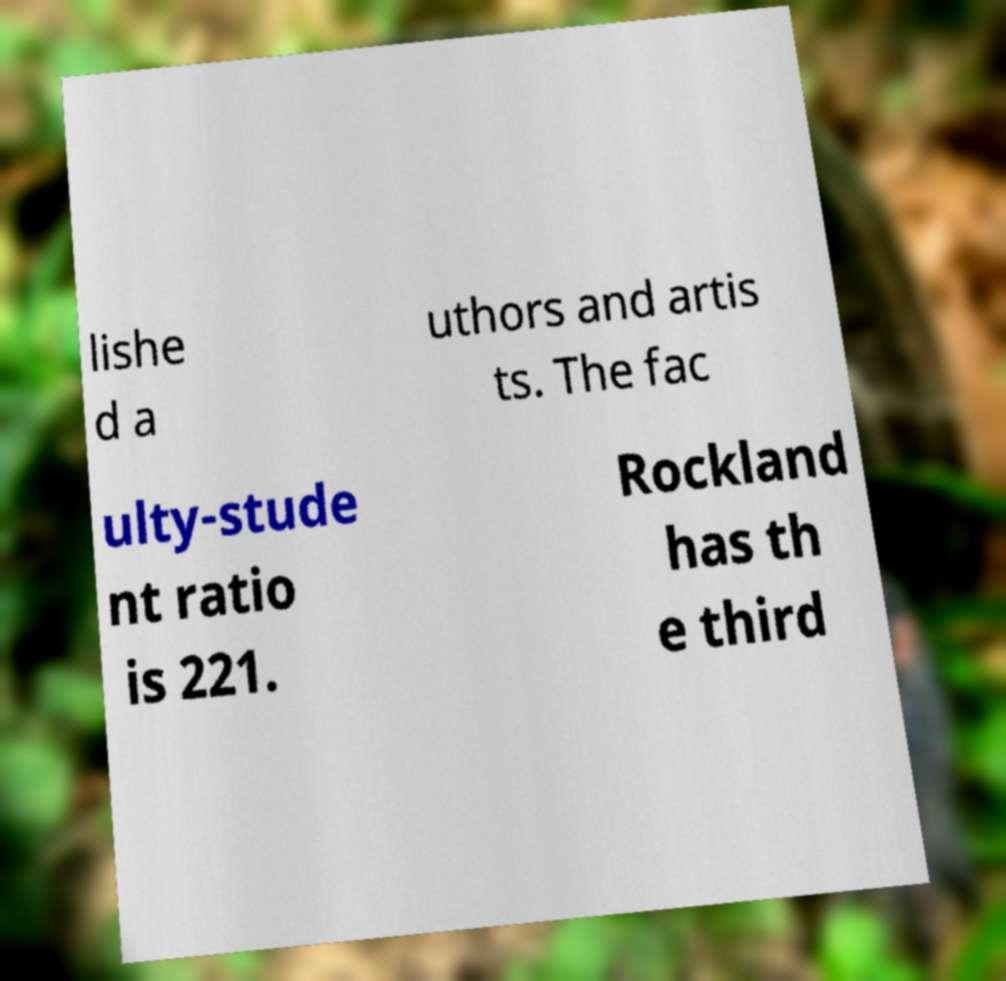I need the written content from this picture converted into text. Can you do that? lishe d a uthors and artis ts. The fac ulty-stude nt ratio is 221. Rockland has th e third 